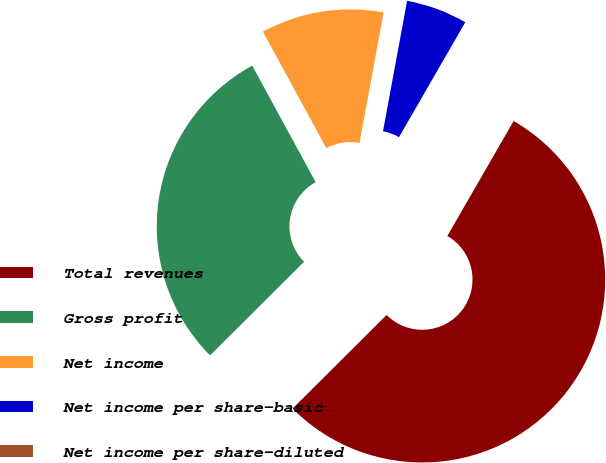Convert chart to OTSL. <chart><loc_0><loc_0><loc_500><loc_500><pie_chart><fcel>Total revenues<fcel>Gross profit<fcel>Net income<fcel>Net income per share-basic<fcel>Net income per share-diluted<nl><fcel>54.21%<fcel>29.53%<fcel>10.84%<fcel>5.42%<fcel>0.0%<nl></chart> 